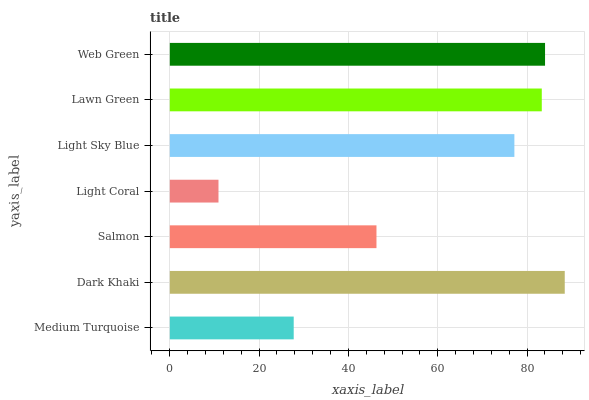Is Light Coral the minimum?
Answer yes or no. Yes. Is Dark Khaki the maximum?
Answer yes or no. Yes. Is Salmon the minimum?
Answer yes or no. No. Is Salmon the maximum?
Answer yes or no. No. Is Dark Khaki greater than Salmon?
Answer yes or no. Yes. Is Salmon less than Dark Khaki?
Answer yes or no. Yes. Is Salmon greater than Dark Khaki?
Answer yes or no. No. Is Dark Khaki less than Salmon?
Answer yes or no. No. Is Light Sky Blue the high median?
Answer yes or no. Yes. Is Light Sky Blue the low median?
Answer yes or no. Yes. Is Salmon the high median?
Answer yes or no. No. Is Salmon the low median?
Answer yes or no. No. 